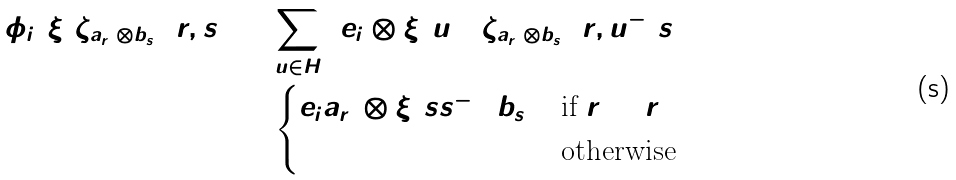<formula> <loc_0><loc_0><loc_500><loc_500>\phi _ { i } ( \xi ) \zeta _ { a _ { r _ { 1 } } \otimes b _ { s _ { 1 } } } ( r , s ) & = \sum _ { u \in H } \left ( e _ { i } \otimes \xi ( u ) \right ) \zeta _ { a _ { r _ { 1 } } \otimes b _ { s _ { 1 } } } ( r , u ^ { - 1 } s ) \\ & = \begin{cases} e _ { i } a _ { r _ { 1 } } \otimes \xi ( s s _ { 1 } ^ { - 1 } ) b _ { s _ { 1 } } & \text {if } r = r _ { 1 } \\ 0 & \text {otherwise} \end{cases}</formula> 